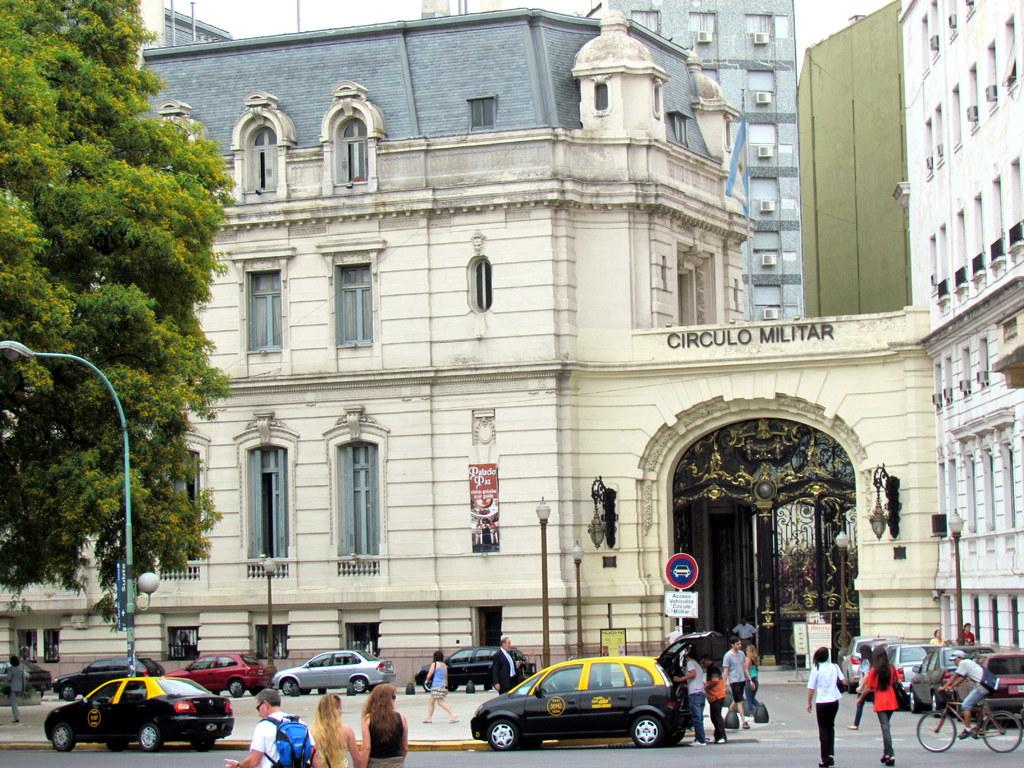<image>
Write a terse but informative summary of the picture. circulo militar that is above the land with people 